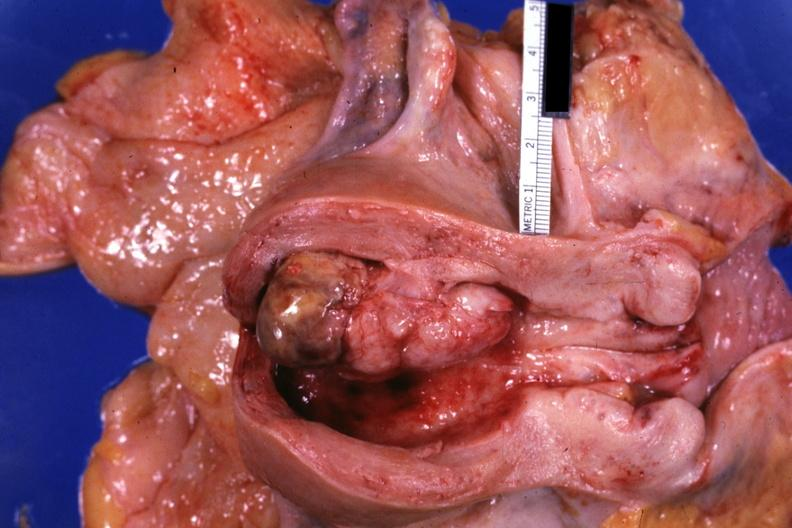s leiomyosarcoma opened uterus shows tumor?
Answer the question using a single word or phrase. No 